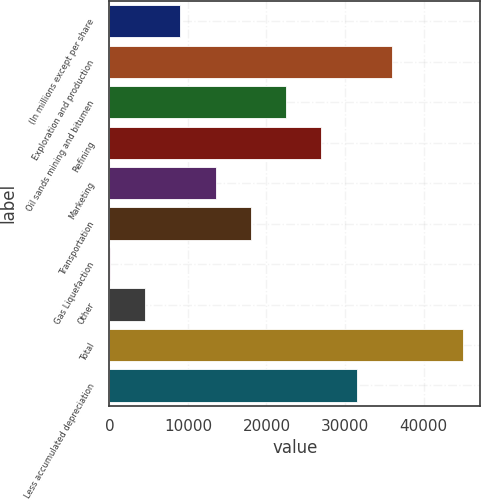<chart> <loc_0><loc_0><loc_500><loc_500><bar_chart><fcel>(In millions except per share<fcel>Exploration and production<fcel>Oil sands mining and bitumen<fcel>Refining<fcel>Marketing<fcel>Transportation<fcel>Gas Liquefaction<fcel>Other<fcel>Total<fcel>Less accumulated depreciation<nl><fcel>9019.8<fcel>36001.2<fcel>22510.5<fcel>27007.4<fcel>13516.7<fcel>18013.6<fcel>26<fcel>4522.9<fcel>44995<fcel>31504.3<nl></chart> 